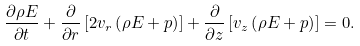Convert formula to latex. <formula><loc_0><loc_0><loc_500><loc_500>\frac { \partial \rho E } { \partial t } + \frac { \partial } { \partial r } \left [ 2 v _ { r } \left ( \rho E + p \right ) \right ] + \frac { \partial } { \partial z } \left [ v _ { z } \left ( \rho E + p \right ) \right ] = 0 .</formula> 